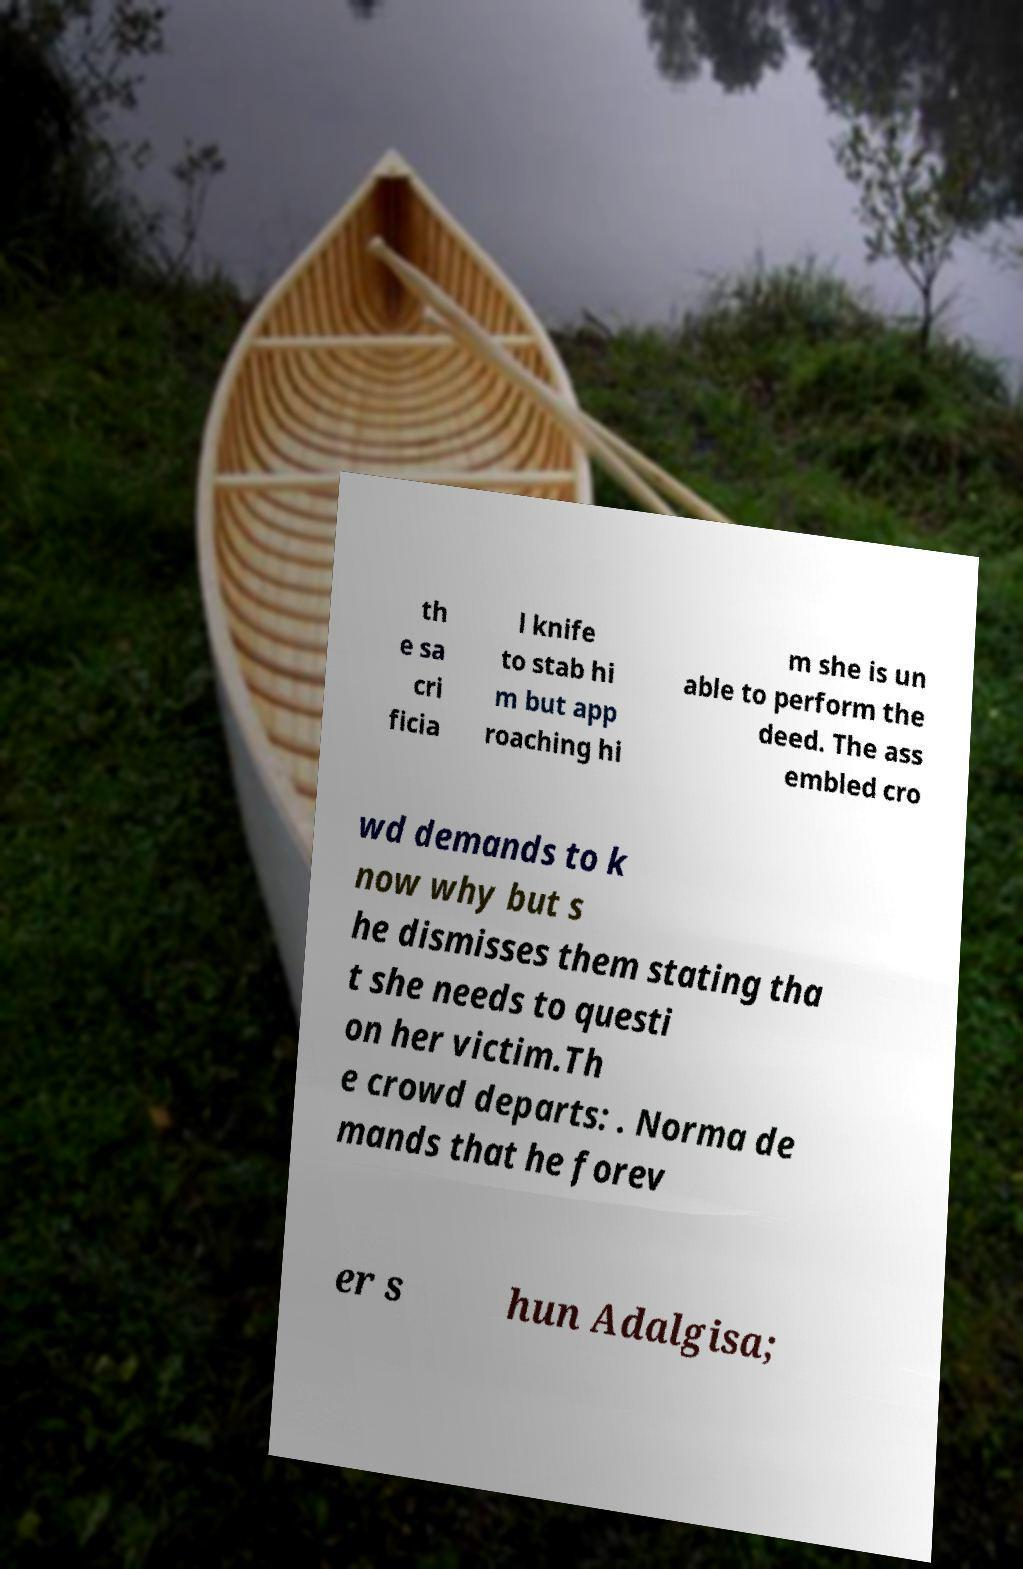What messages or text are displayed in this image? I need them in a readable, typed format. th e sa cri ficia l knife to stab hi m but app roaching hi m she is un able to perform the deed. The ass embled cro wd demands to k now why but s he dismisses them stating tha t she needs to questi on her victim.Th e crowd departs: . Norma de mands that he forev er s hun Adalgisa; 